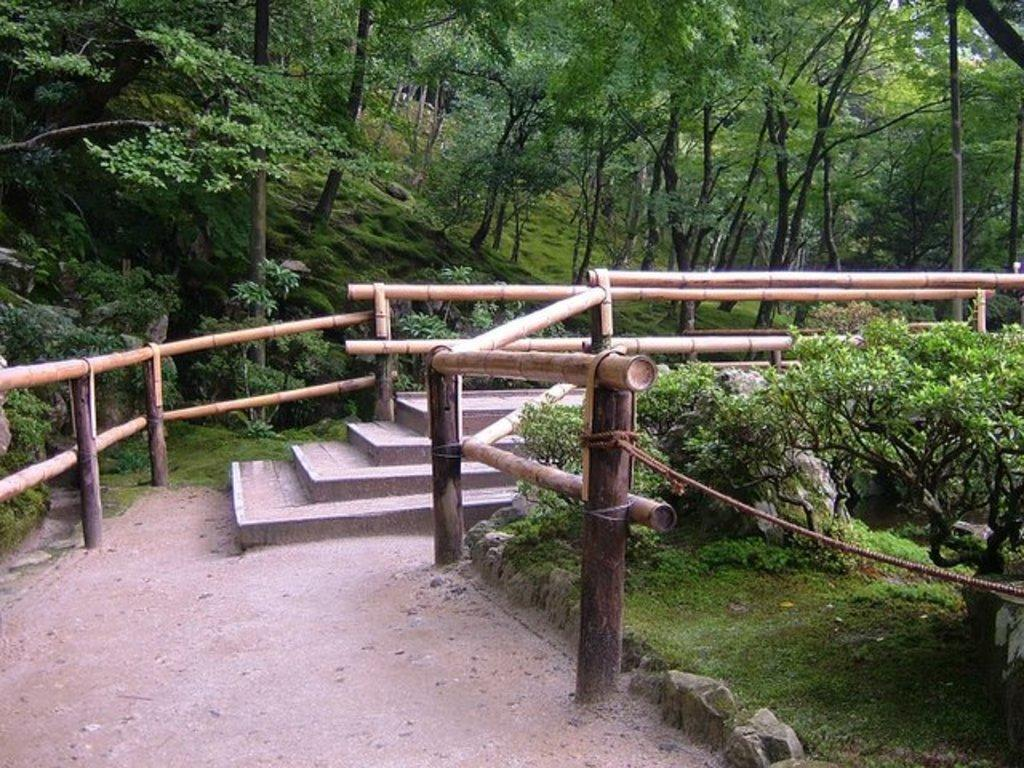What type of vegetation can be seen in the image? There are many trees in the image. What is the ground covered with in the image? There is grass visible in the image. What type of barrier is present along the road in the image? There is a fencing along the road in the image. What is the hope for the day in the image? There is no indication of hope or any specific day in the image; it primarily features trees, grass, and a fencing along the road. 